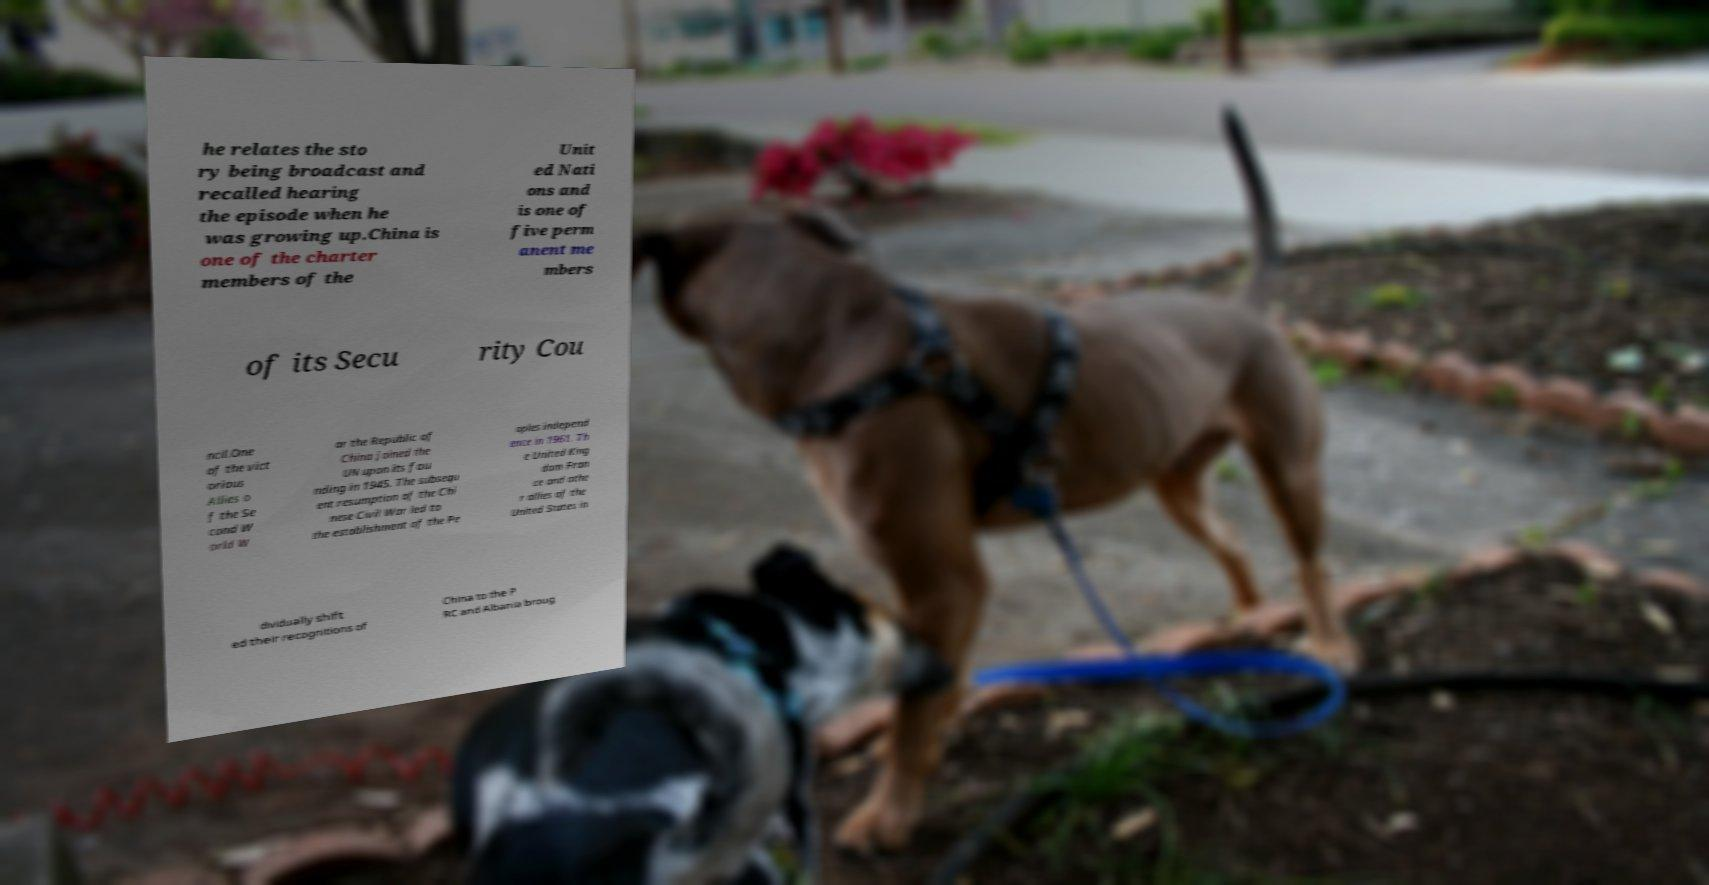I need the written content from this picture converted into text. Can you do that? he relates the sto ry being broadcast and recalled hearing the episode when he was growing up.China is one of the charter members of the Unit ed Nati ons and is one of five perm anent me mbers of its Secu rity Cou ncil.One of the vict orious Allies o f the Se cond W orld W ar the Republic of China joined the UN upon its fou nding in 1945. The subsequ ent resumption of the Chi nese Civil War led to the establishment of the Pe oples independ ence in 1961. Th e United King dom Fran ce and othe r allies of the United States in dividually shift ed their recognitions of China to the P RC and Albania broug 